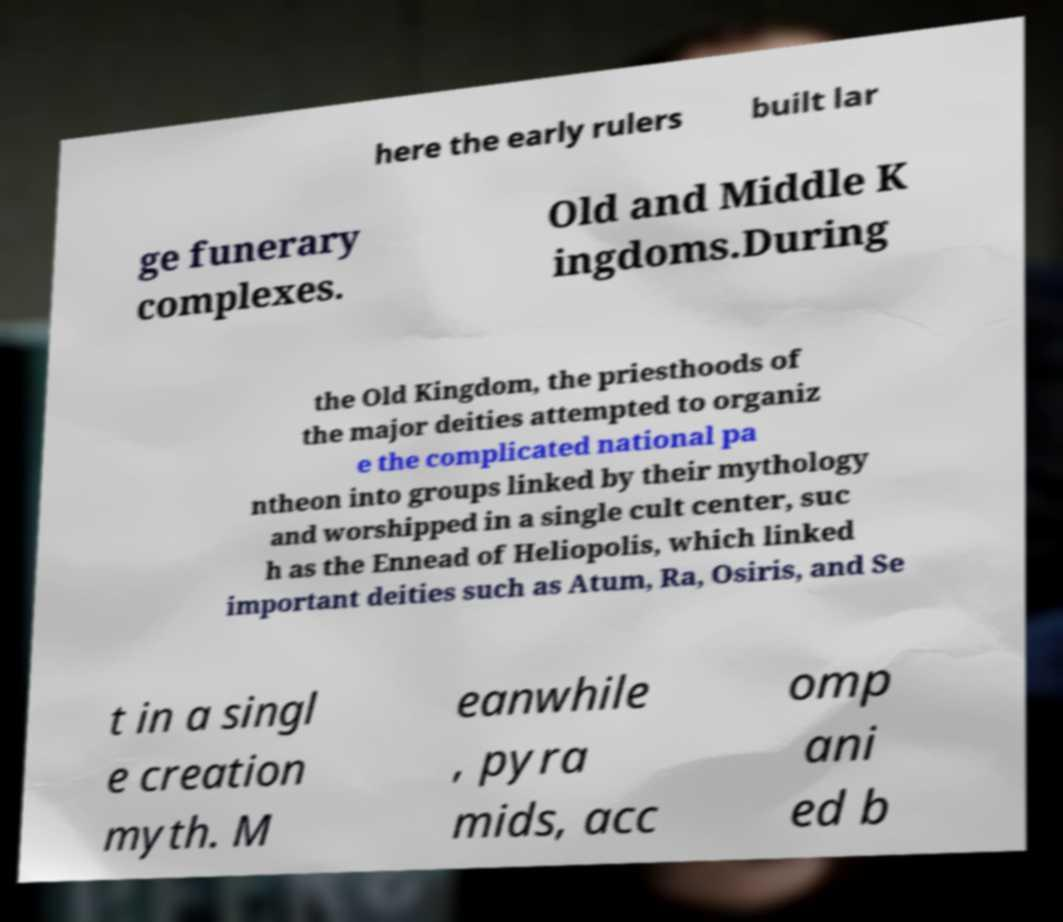Can you accurately transcribe the text from the provided image for me? here the early rulers built lar ge funerary complexes. Old and Middle K ingdoms.During the Old Kingdom, the priesthoods of the major deities attempted to organiz e the complicated national pa ntheon into groups linked by their mythology and worshipped in a single cult center, suc h as the Ennead of Heliopolis, which linked important deities such as Atum, Ra, Osiris, and Se t in a singl e creation myth. M eanwhile , pyra mids, acc omp ani ed b 